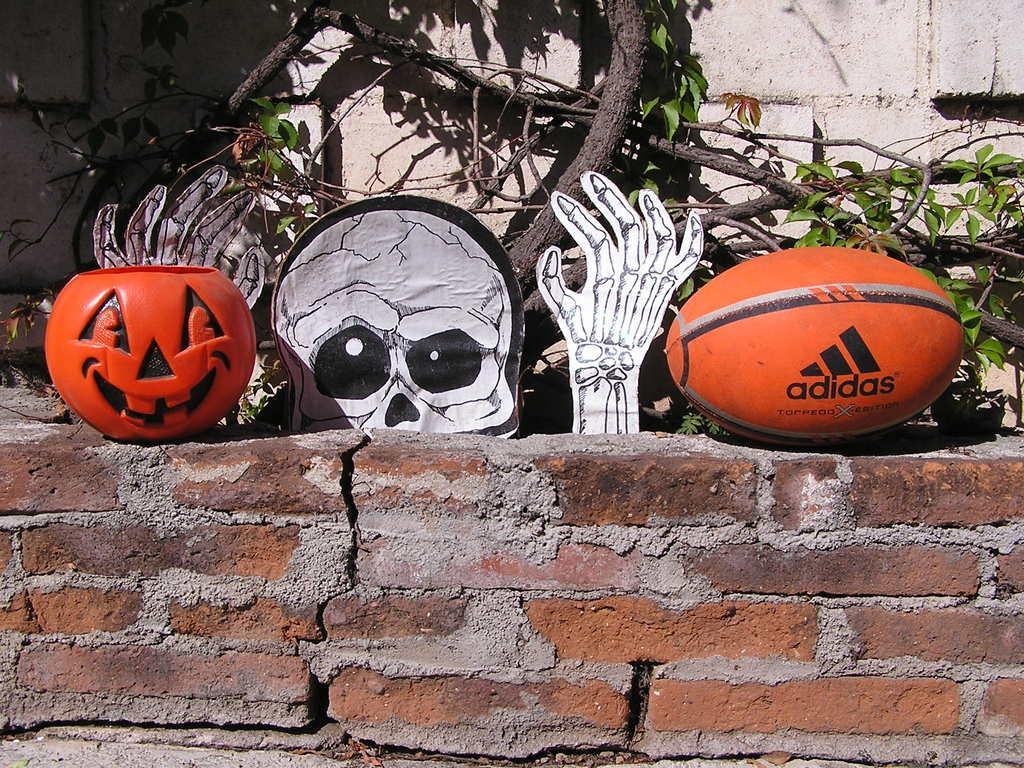What is in the foreground of the picture? There is a brick wall in the foreground of the picture. What objects are on the brick wall? There is a ball, a pumpkin, and a toy on the brick wall. What can be seen in the background of the picture? There are trees and another wall in the background of the picture. What is the weather like in the image? The weather is sunny. What type of pan is being used to cook the pumpkin in the image? There is no pan or cooking activity present in the image; it features a brick wall with objects on it. What historical event is being commemorated by the objects on the wall? There is no indication of a historical event or commemoration in the image; it simply shows a brick wall with objects on it. 